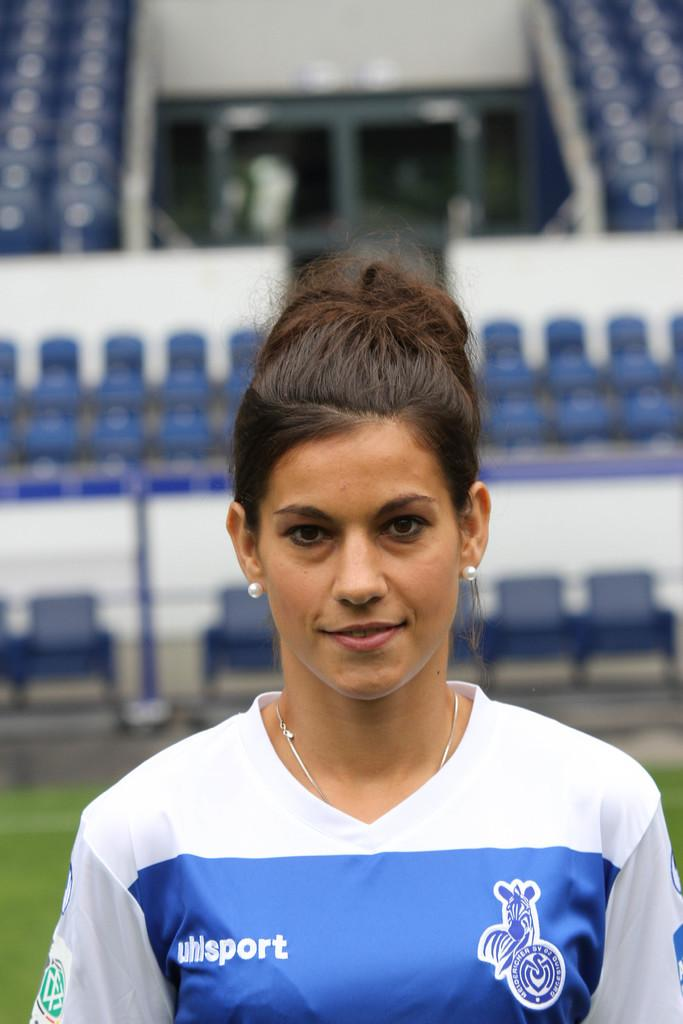<image>
Summarize the visual content of the image. A woman with a blue and white shirt that says uhlsport stands in front of stadium seating. 